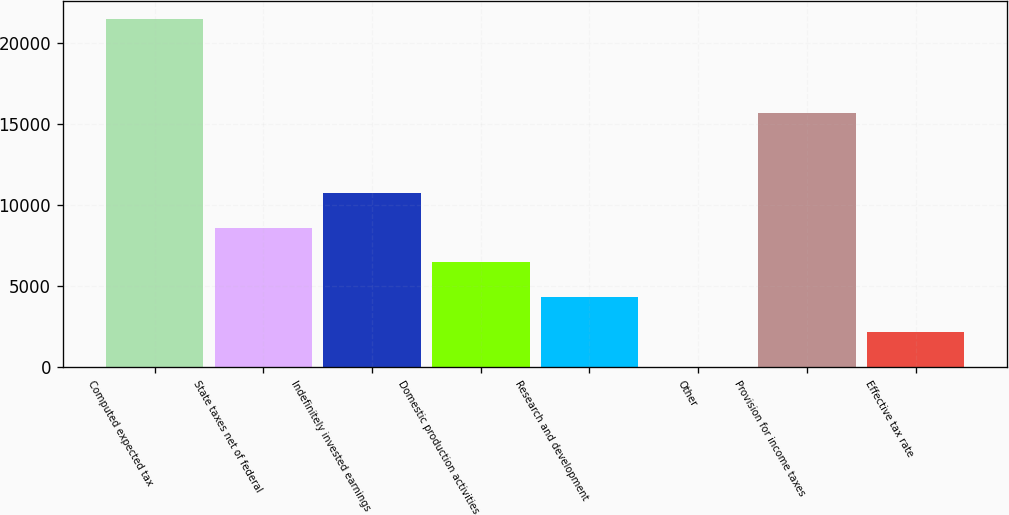<chart> <loc_0><loc_0><loc_500><loc_500><bar_chart><fcel>Computed expected tax<fcel>State taxes net of federal<fcel>Indefinitely invested earnings<fcel>Domestic production activities<fcel>Research and development<fcel>Other<fcel>Provision for income taxes<fcel>Effective tax rate<nl><fcel>21480<fcel>8599.8<fcel>10746.5<fcel>6453.1<fcel>4306.4<fcel>13<fcel>15685<fcel>2159.7<nl></chart> 